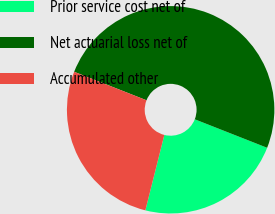<chart> <loc_0><loc_0><loc_500><loc_500><pie_chart><fcel>Prior service cost net of<fcel>Net actuarial loss net of<fcel>Accumulated other<nl><fcel>22.95%<fcel>50.0%<fcel>27.05%<nl></chart> 